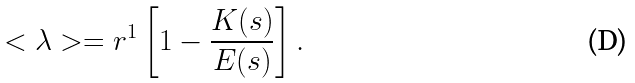Convert formula to latex. <formula><loc_0><loc_0><loc_500><loc_500>< \lambda > = r ^ { 1 } \left [ 1 - \frac { K ( s ) } { E ( s ) } \right ] .</formula> 